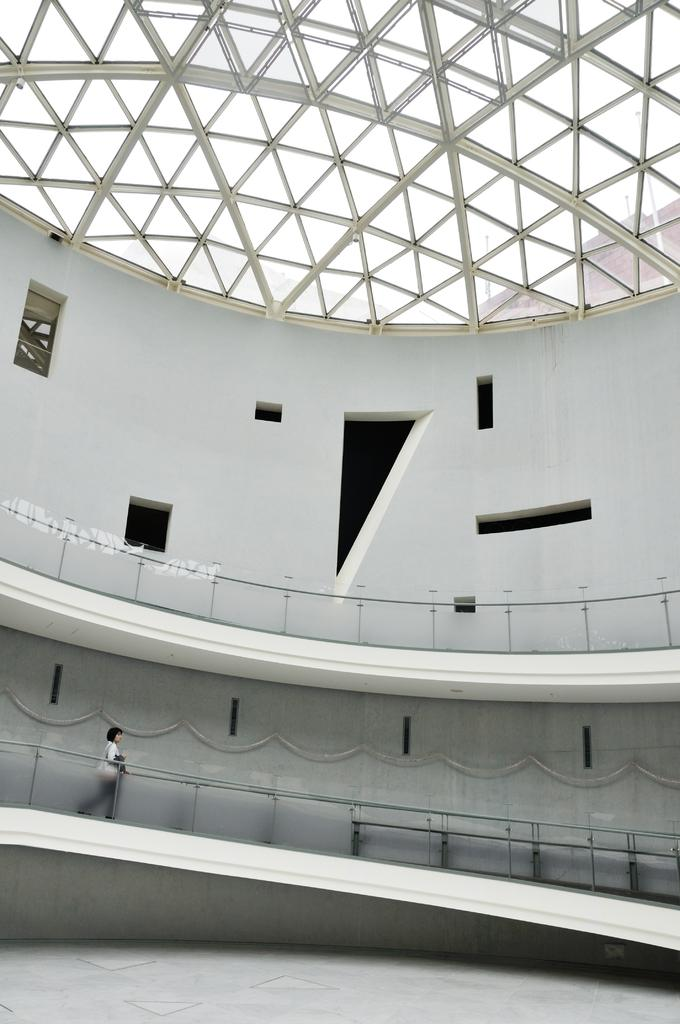What is the main subject of the image? The main subject of the image is a woman. What is the woman doing in the image? The woman is standing on the ground. What structure is visible in the image? There is a building in the image. What type of development can be seen taking place in the image? There is no development taking place in the image; it features a woman standing on the ground and a building. What type of pleasure is the woman experiencing in the image? There is no indication of the woman experiencing any specific pleasure in the image. 